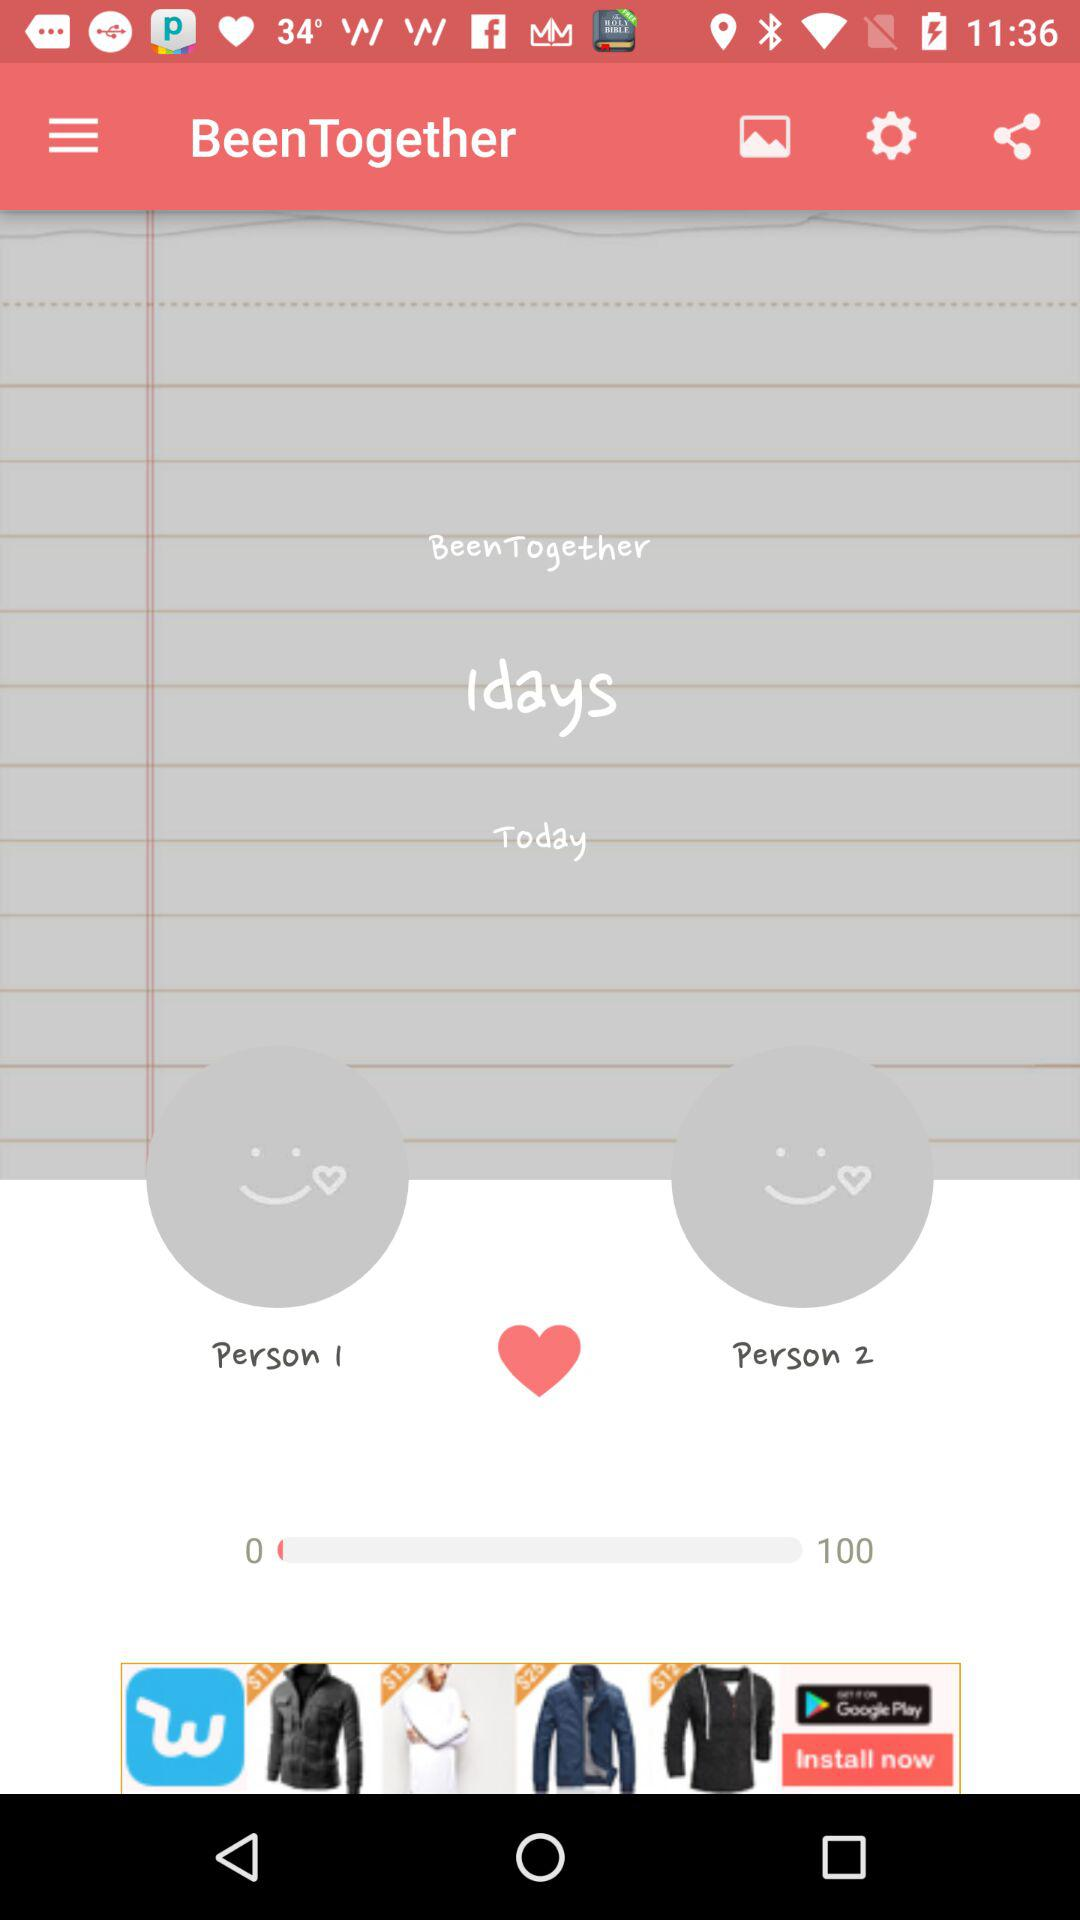How many people are there in total?
When the provided information is insufficient, respond with <no answer>. <no answer> 